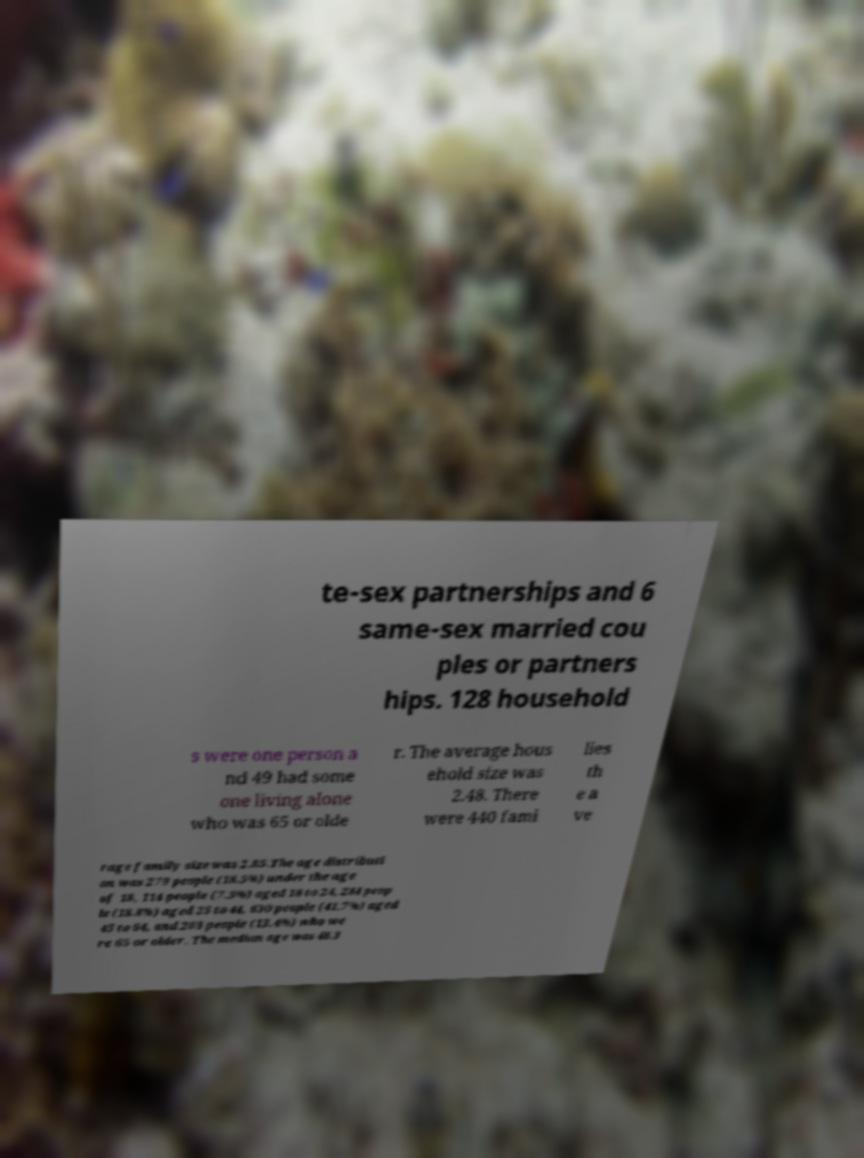What messages or text are displayed in this image? I need them in a readable, typed format. te-sex partnerships and 6 same-sex married cou ples or partners hips. 128 household s were one person a nd 49 had some one living alone who was 65 or olde r. The average hous ehold size was 2.48. There were 440 fami lies th e a ve rage family size was 2.85.The age distributi on was 279 people (18.5%) under the age of 18, 114 people (7.5%) aged 18 to 24, 284 peop le (18.8%) aged 25 to 44, 630 people (41.7%) aged 45 to 64, and 203 people (13.4%) who we re 65 or older. The median age was 48.3 